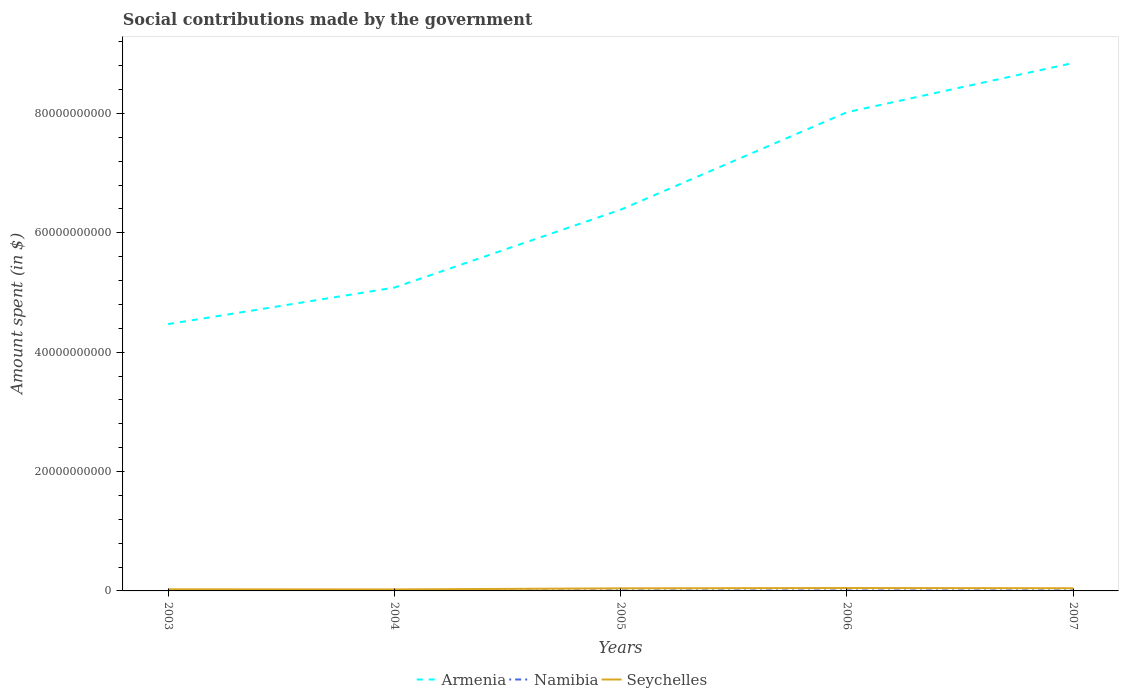How many different coloured lines are there?
Your answer should be compact. 3. Across all years, what is the maximum amount spent on social contributions in Seychelles?
Ensure brevity in your answer.  2.50e+08. In which year was the amount spent on social contributions in Seychelles maximum?
Offer a terse response. 2004. What is the total amount spent on social contributions in Namibia in the graph?
Offer a terse response. -4.47e+06. What is the difference between the highest and the second highest amount spent on social contributions in Namibia?
Provide a succinct answer. 2.15e+07. What is the difference between the highest and the lowest amount spent on social contributions in Namibia?
Provide a short and direct response. 3. How many lines are there?
Your response must be concise. 3. How many years are there in the graph?
Offer a terse response. 5. What is the difference between two consecutive major ticks on the Y-axis?
Ensure brevity in your answer.  2.00e+1. Are the values on the major ticks of Y-axis written in scientific E-notation?
Give a very brief answer. No. Does the graph contain any zero values?
Your answer should be compact. No. How are the legend labels stacked?
Give a very brief answer. Horizontal. What is the title of the graph?
Make the answer very short. Social contributions made by the government. What is the label or title of the X-axis?
Ensure brevity in your answer.  Years. What is the label or title of the Y-axis?
Make the answer very short. Amount spent (in $). What is the Amount spent (in $) of Armenia in 2003?
Make the answer very short. 4.47e+1. What is the Amount spent (in $) in Namibia in 2003?
Offer a very short reply. 5.99e+07. What is the Amount spent (in $) in Seychelles in 2003?
Keep it short and to the point. 2.70e+08. What is the Amount spent (in $) of Armenia in 2004?
Make the answer very short. 5.08e+1. What is the Amount spent (in $) in Namibia in 2004?
Ensure brevity in your answer.  6.90e+07. What is the Amount spent (in $) in Seychelles in 2004?
Provide a short and direct response. 2.50e+08. What is the Amount spent (in $) of Armenia in 2005?
Your answer should be compact. 6.39e+1. What is the Amount spent (in $) of Namibia in 2005?
Make the answer very short. 7.69e+07. What is the Amount spent (in $) in Seychelles in 2005?
Your response must be concise. 4.32e+08. What is the Amount spent (in $) of Armenia in 2006?
Offer a very short reply. 8.02e+1. What is the Amount spent (in $) in Namibia in 2006?
Offer a terse response. 7.47e+07. What is the Amount spent (in $) in Seychelles in 2006?
Your answer should be very brief. 4.84e+08. What is the Amount spent (in $) in Armenia in 2007?
Provide a short and direct response. 8.85e+1. What is the Amount spent (in $) in Namibia in 2007?
Provide a short and direct response. 8.14e+07. What is the Amount spent (in $) of Seychelles in 2007?
Offer a terse response. 4.50e+08. Across all years, what is the maximum Amount spent (in $) of Armenia?
Provide a short and direct response. 8.85e+1. Across all years, what is the maximum Amount spent (in $) of Namibia?
Keep it short and to the point. 8.14e+07. Across all years, what is the maximum Amount spent (in $) of Seychelles?
Make the answer very short. 4.84e+08. Across all years, what is the minimum Amount spent (in $) of Armenia?
Your answer should be compact. 4.47e+1. Across all years, what is the minimum Amount spent (in $) of Namibia?
Your response must be concise. 5.99e+07. Across all years, what is the minimum Amount spent (in $) in Seychelles?
Your answer should be very brief. 2.50e+08. What is the total Amount spent (in $) in Armenia in the graph?
Offer a very short reply. 3.28e+11. What is the total Amount spent (in $) in Namibia in the graph?
Offer a very short reply. 3.62e+08. What is the total Amount spent (in $) in Seychelles in the graph?
Provide a short and direct response. 1.89e+09. What is the difference between the Amount spent (in $) in Armenia in 2003 and that in 2004?
Offer a very short reply. -6.12e+09. What is the difference between the Amount spent (in $) of Namibia in 2003 and that in 2004?
Offer a very short reply. -9.08e+06. What is the difference between the Amount spent (in $) in Seychelles in 2003 and that in 2004?
Ensure brevity in your answer.  1.93e+07. What is the difference between the Amount spent (in $) in Armenia in 2003 and that in 2005?
Offer a very short reply. -1.92e+1. What is the difference between the Amount spent (in $) of Namibia in 2003 and that in 2005?
Your answer should be compact. -1.70e+07. What is the difference between the Amount spent (in $) in Seychelles in 2003 and that in 2005?
Offer a very short reply. -1.62e+08. What is the difference between the Amount spent (in $) in Armenia in 2003 and that in 2006?
Offer a terse response. -3.55e+1. What is the difference between the Amount spent (in $) in Namibia in 2003 and that in 2006?
Make the answer very short. -1.48e+07. What is the difference between the Amount spent (in $) in Seychelles in 2003 and that in 2006?
Offer a terse response. -2.14e+08. What is the difference between the Amount spent (in $) in Armenia in 2003 and that in 2007?
Your answer should be very brief. -4.38e+1. What is the difference between the Amount spent (in $) of Namibia in 2003 and that in 2007?
Your answer should be very brief. -2.15e+07. What is the difference between the Amount spent (in $) of Seychelles in 2003 and that in 2007?
Offer a terse response. -1.81e+08. What is the difference between the Amount spent (in $) of Armenia in 2004 and that in 2005?
Your answer should be very brief. -1.31e+1. What is the difference between the Amount spent (in $) in Namibia in 2004 and that in 2005?
Offer a very short reply. -7.95e+06. What is the difference between the Amount spent (in $) in Seychelles in 2004 and that in 2005?
Provide a succinct answer. -1.82e+08. What is the difference between the Amount spent (in $) of Armenia in 2004 and that in 2006?
Keep it short and to the point. -2.94e+1. What is the difference between the Amount spent (in $) of Namibia in 2004 and that in 2006?
Make the answer very short. -5.71e+06. What is the difference between the Amount spent (in $) in Seychelles in 2004 and that in 2006?
Provide a succinct answer. -2.33e+08. What is the difference between the Amount spent (in $) of Armenia in 2004 and that in 2007?
Your answer should be very brief. -3.76e+1. What is the difference between the Amount spent (in $) of Namibia in 2004 and that in 2007?
Give a very brief answer. -1.24e+07. What is the difference between the Amount spent (in $) of Seychelles in 2004 and that in 2007?
Offer a very short reply. -2.00e+08. What is the difference between the Amount spent (in $) of Armenia in 2005 and that in 2006?
Offer a very short reply. -1.63e+1. What is the difference between the Amount spent (in $) in Namibia in 2005 and that in 2006?
Offer a terse response. 2.24e+06. What is the difference between the Amount spent (in $) in Seychelles in 2005 and that in 2006?
Provide a succinct answer. -5.19e+07. What is the difference between the Amount spent (in $) in Armenia in 2005 and that in 2007?
Offer a terse response. -2.46e+1. What is the difference between the Amount spent (in $) of Namibia in 2005 and that in 2007?
Keep it short and to the point. -4.47e+06. What is the difference between the Amount spent (in $) of Seychelles in 2005 and that in 2007?
Offer a very short reply. -1.84e+07. What is the difference between the Amount spent (in $) in Armenia in 2006 and that in 2007?
Offer a very short reply. -8.26e+09. What is the difference between the Amount spent (in $) of Namibia in 2006 and that in 2007?
Provide a short and direct response. -6.71e+06. What is the difference between the Amount spent (in $) of Seychelles in 2006 and that in 2007?
Offer a very short reply. 3.35e+07. What is the difference between the Amount spent (in $) of Armenia in 2003 and the Amount spent (in $) of Namibia in 2004?
Provide a short and direct response. 4.46e+1. What is the difference between the Amount spent (in $) of Armenia in 2003 and the Amount spent (in $) of Seychelles in 2004?
Keep it short and to the point. 4.45e+1. What is the difference between the Amount spent (in $) in Namibia in 2003 and the Amount spent (in $) in Seychelles in 2004?
Provide a succinct answer. -1.91e+08. What is the difference between the Amount spent (in $) in Armenia in 2003 and the Amount spent (in $) in Namibia in 2005?
Provide a succinct answer. 4.46e+1. What is the difference between the Amount spent (in $) of Armenia in 2003 and the Amount spent (in $) of Seychelles in 2005?
Make the answer very short. 4.43e+1. What is the difference between the Amount spent (in $) of Namibia in 2003 and the Amount spent (in $) of Seychelles in 2005?
Keep it short and to the point. -3.72e+08. What is the difference between the Amount spent (in $) in Armenia in 2003 and the Amount spent (in $) in Namibia in 2006?
Offer a terse response. 4.46e+1. What is the difference between the Amount spent (in $) in Armenia in 2003 and the Amount spent (in $) in Seychelles in 2006?
Your response must be concise. 4.42e+1. What is the difference between the Amount spent (in $) of Namibia in 2003 and the Amount spent (in $) of Seychelles in 2006?
Offer a terse response. -4.24e+08. What is the difference between the Amount spent (in $) of Armenia in 2003 and the Amount spent (in $) of Namibia in 2007?
Provide a short and direct response. 4.46e+1. What is the difference between the Amount spent (in $) in Armenia in 2003 and the Amount spent (in $) in Seychelles in 2007?
Offer a terse response. 4.43e+1. What is the difference between the Amount spent (in $) in Namibia in 2003 and the Amount spent (in $) in Seychelles in 2007?
Provide a succinct answer. -3.90e+08. What is the difference between the Amount spent (in $) of Armenia in 2004 and the Amount spent (in $) of Namibia in 2005?
Offer a very short reply. 5.08e+1. What is the difference between the Amount spent (in $) of Armenia in 2004 and the Amount spent (in $) of Seychelles in 2005?
Ensure brevity in your answer.  5.04e+1. What is the difference between the Amount spent (in $) in Namibia in 2004 and the Amount spent (in $) in Seychelles in 2005?
Offer a terse response. -3.63e+08. What is the difference between the Amount spent (in $) in Armenia in 2004 and the Amount spent (in $) in Namibia in 2006?
Your response must be concise. 5.08e+1. What is the difference between the Amount spent (in $) in Armenia in 2004 and the Amount spent (in $) in Seychelles in 2006?
Keep it short and to the point. 5.03e+1. What is the difference between the Amount spent (in $) in Namibia in 2004 and the Amount spent (in $) in Seychelles in 2006?
Ensure brevity in your answer.  -4.15e+08. What is the difference between the Amount spent (in $) of Armenia in 2004 and the Amount spent (in $) of Namibia in 2007?
Provide a short and direct response. 5.07e+1. What is the difference between the Amount spent (in $) in Armenia in 2004 and the Amount spent (in $) in Seychelles in 2007?
Give a very brief answer. 5.04e+1. What is the difference between the Amount spent (in $) of Namibia in 2004 and the Amount spent (in $) of Seychelles in 2007?
Your answer should be very brief. -3.81e+08. What is the difference between the Amount spent (in $) of Armenia in 2005 and the Amount spent (in $) of Namibia in 2006?
Your response must be concise. 6.38e+1. What is the difference between the Amount spent (in $) of Armenia in 2005 and the Amount spent (in $) of Seychelles in 2006?
Offer a terse response. 6.34e+1. What is the difference between the Amount spent (in $) in Namibia in 2005 and the Amount spent (in $) in Seychelles in 2006?
Your response must be concise. -4.07e+08. What is the difference between the Amount spent (in $) of Armenia in 2005 and the Amount spent (in $) of Namibia in 2007?
Provide a short and direct response. 6.38e+1. What is the difference between the Amount spent (in $) of Armenia in 2005 and the Amount spent (in $) of Seychelles in 2007?
Your answer should be compact. 6.34e+1. What is the difference between the Amount spent (in $) of Namibia in 2005 and the Amount spent (in $) of Seychelles in 2007?
Ensure brevity in your answer.  -3.73e+08. What is the difference between the Amount spent (in $) in Armenia in 2006 and the Amount spent (in $) in Namibia in 2007?
Offer a very short reply. 8.01e+1. What is the difference between the Amount spent (in $) of Armenia in 2006 and the Amount spent (in $) of Seychelles in 2007?
Offer a terse response. 7.98e+1. What is the difference between the Amount spent (in $) of Namibia in 2006 and the Amount spent (in $) of Seychelles in 2007?
Your answer should be very brief. -3.76e+08. What is the average Amount spent (in $) of Armenia per year?
Ensure brevity in your answer.  6.56e+1. What is the average Amount spent (in $) of Namibia per year?
Provide a short and direct response. 7.24e+07. What is the average Amount spent (in $) in Seychelles per year?
Give a very brief answer. 3.77e+08. In the year 2003, what is the difference between the Amount spent (in $) in Armenia and Amount spent (in $) in Namibia?
Your response must be concise. 4.47e+1. In the year 2003, what is the difference between the Amount spent (in $) in Armenia and Amount spent (in $) in Seychelles?
Keep it short and to the point. 4.44e+1. In the year 2003, what is the difference between the Amount spent (in $) in Namibia and Amount spent (in $) in Seychelles?
Make the answer very short. -2.10e+08. In the year 2004, what is the difference between the Amount spent (in $) in Armenia and Amount spent (in $) in Namibia?
Make the answer very short. 5.08e+1. In the year 2004, what is the difference between the Amount spent (in $) of Armenia and Amount spent (in $) of Seychelles?
Give a very brief answer. 5.06e+1. In the year 2004, what is the difference between the Amount spent (in $) of Namibia and Amount spent (in $) of Seychelles?
Offer a terse response. -1.81e+08. In the year 2005, what is the difference between the Amount spent (in $) in Armenia and Amount spent (in $) in Namibia?
Your response must be concise. 6.38e+1. In the year 2005, what is the difference between the Amount spent (in $) of Armenia and Amount spent (in $) of Seychelles?
Ensure brevity in your answer.  6.34e+1. In the year 2005, what is the difference between the Amount spent (in $) of Namibia and Amount spent (in $) of Seychelles?
Your response must be concise. -3.55e+08. In the year 2006, what is the difference between the Amount spent (in $) in Armenia and Amount spent (in $) in Namibia?
Your answer should be compact. 8.01e+1. In the year 2006, what is the difference between the Amount spent (in $) of Armenia and Amount spent (in $) of Seychelles?
Keep it short and to the point. 7.97e+1. In the year 2006, what is the difference between the Amount spent (in $) in Namibia and Amount spent (in $) in Seychelles?
Your answer should be compact. -4.09e+08. In the year 2007, what is the difference between the Amount spent (in $) of Armenia and Amount spent (in $) of Namibia?
Offer a terse response. 8.84e+1. In the year 2007, what is the difference between the Amount spent (in $) of Armenia and Amount spent (in $) of Seychelles?
Provide a short and direct response. 8.80e+1. In the year 2007, what is the difference between the Amount spent (in $) of Namibia and Amount spent (in $) of Seychelles?
Keep it short and to the point. -3.69e+08. What is the ratio of the Amount spent (in $) of Armenia in 2003 to that in 2004?
Provide a succinct answer. 0.88. What is the ratio of the Amount spent (in $) of Namibia in 2003 to that in 2004?
Your answer should be compact. 0.87. What is the ratio of the Amount spent (in $) in Seychelles in 2003 to that in 2004?
Provide a succinct answer. 1.08. What is the ratio of the Amount spent (in $) of Armenia in 2003 to that in 2005?
Ensure brevity in your answer.  0.7. What is the ratio of the Amount spent (in $) of Namibia in 2003 to that in 2005?
Offer a very short reply. 0.78. What is the ratio of the Amount spent (in $) in Seychelles in 2003 to that in 2005?
Provide a short and direct response. 0.62. What is the ratio of the Amount spent (in $) of Armenia in 2003 to that in 2006?
Ensure brevity in your answer.  0.56. What is the ratio of the Amount spent (in $) in Namibia in 2003 to that in 2006?
Your answer should be very brief. 0.8. What is the ratio of the Amount spent (in $) of Seychelles in 2003 to that in 2006?
Provide a short and direct response. 0.56. What is the ratio of the Amount spent (in $) of Armenia in 2003 to that in 2007?
Your answer should be very brief. 0.51. What is the ratio of the Amount spent (in $) of Namibia in 2003 to that in 2007?
Keep it short and to the point. 0.74. What is the ratio of the Amount spent (in $) in Seychelles in 2003 to that in 2007?
Offer a very short reply. 0.6. What is the ratio of the Amount spent (in $) in Armenia in 2004 to that in 2005?
Offer a terse response. 0.8. What is the ratio of the Amount spent (in $) of Namibia in 2004 to that in 2005?
Give a very brief answer. 0.9. What is the ratio of the Amount spent (in $) in Seychelles in 2004 to that in 2005?
Keep it short and to the point. 0.58. What is the ratio of the Amount spent (in $) of Armenia in 2004 to that in 2006?
Offer a very short reply. 0.63. What is the ratio of the Amount spent (in $) of Namibia in 2004 to that in 2006?
Give a very brief answer. 0.92. What is the ratio of the Amount spent (in $) in Seychelles in 2004 to that in 2006?
Provide a short and direct response. 0.52. What is the ratio of the Amount spent (in $) in Armenia in 2004 to that in 2007?
Provide a succinct answer. 0.57. What is the ratio of the Amount spent (in $) in Namibia in 2004 to that in 2007?
Provide a succinct answer. 0.85. What is the ratio of the Amount spent (in $) in Seychelles in 2004 to that in 2007?
Give a very brief answer. 0.56. What is the ratio of the Amount spent (in $) of Armenia in 2005 to that in 2006?
Ensure brevity in your answer.  0.8. What is the ratio of the Amount spent (in $) of Namibia in 2005 to that in 2006?
Offer a very short reply. 1.03. What is the ratio of the Amount spent (in $) of Seychelles in 2005 to that in 2006?
Make the answer very short. 0.89. What is the ratio of the Amount spent (in $) in Armenia in 2005 to that in 2007?
Make the answer very short. 0.72. What is the ratio of the Amount spent (in $) of Namibia in 2005 to that in 2007?
Keep it short and to the point. 0.95. What is the ratio of the Amount spent (in $) of Seychelles in 2005 to that in 2007?
Offer a very short reply. 0.96. What is the ratio of the Amount spent (in $) in Armenia in 2006 to that in 2007?
Provide a succinct answer. 0.91. What is the ratio of the Amount spent (in $) in Namibia in 2006 to that in 2007?
Offer a very short reply. 0.92. What is the ratio of the Amount spent (in $) of Seychelles in 2006 to that in 2007?
Your answer should be very brief. 1.07. What is the difference between the highest and the second highest Amount spent (in $) of Armenia?
Provide a succinct answer. 8.26e+09. What is the difference between the highest and the second highest Amount spent (in $) in Namibia?
Make the answer very short. 4.47e+06. What is the difference between the highest and the second highest Amount spent (in $) in Seychelles?
Your answer should be very brief. 3.35e+07. What is the difference between the highest and the lowest Amount spent (in $) in Armenia?
Your response must be concise. 4.38e+1. What is the difference between the highest and the lowest Amount spent (in $) of Namibia?
Provide a short and direct response. 2.15e+07. What is the difference between the highest and the lowest Amount spent (in $) of Seychelles?
Offer a very short reply. 2.33e+08. 